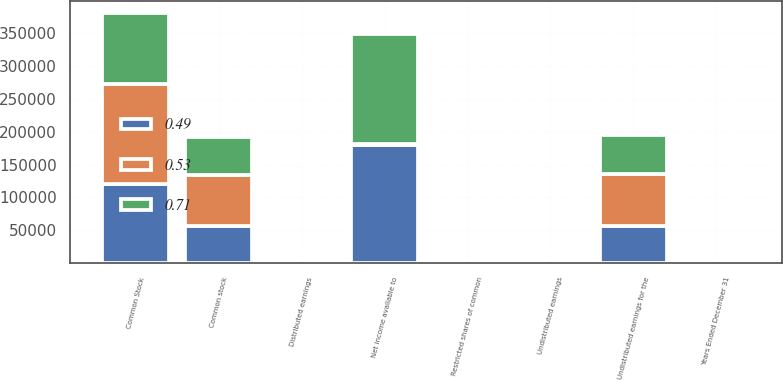Convert chart to OTSL. <chart><loc_0><loc_0><loc_500><loc_500><stacked_bar_chart><ecel><fcel>Years Ended December 31<fcel>Net income available to<fcel>Common Stock<fcel>Restricted shares of common<fcel>Undistributed earnings for the<fcel>Common stock<fcel>Distributed earnings<fcel>Undistributed earnings<nl><fcel>0.53<fcel>2018<fcel>2018<fcel>151458<fcel>1284<fcel>78921<fcel>78255<fcel>0.47<fcel>0.24<nl><fcel>0.49<fcel>2017<fcel>179124<fcel>120930<fcel>1087<fcel>57107<fcel>56567<fcel>0.37<fcel>0.18<nl><fcel>0.71<fcel>2016<fcel>167369<fcel>107880<fcel>1122<fcel>58367<fcel>57722<fcel>0.33<fcel>0.18<nl></chart> 